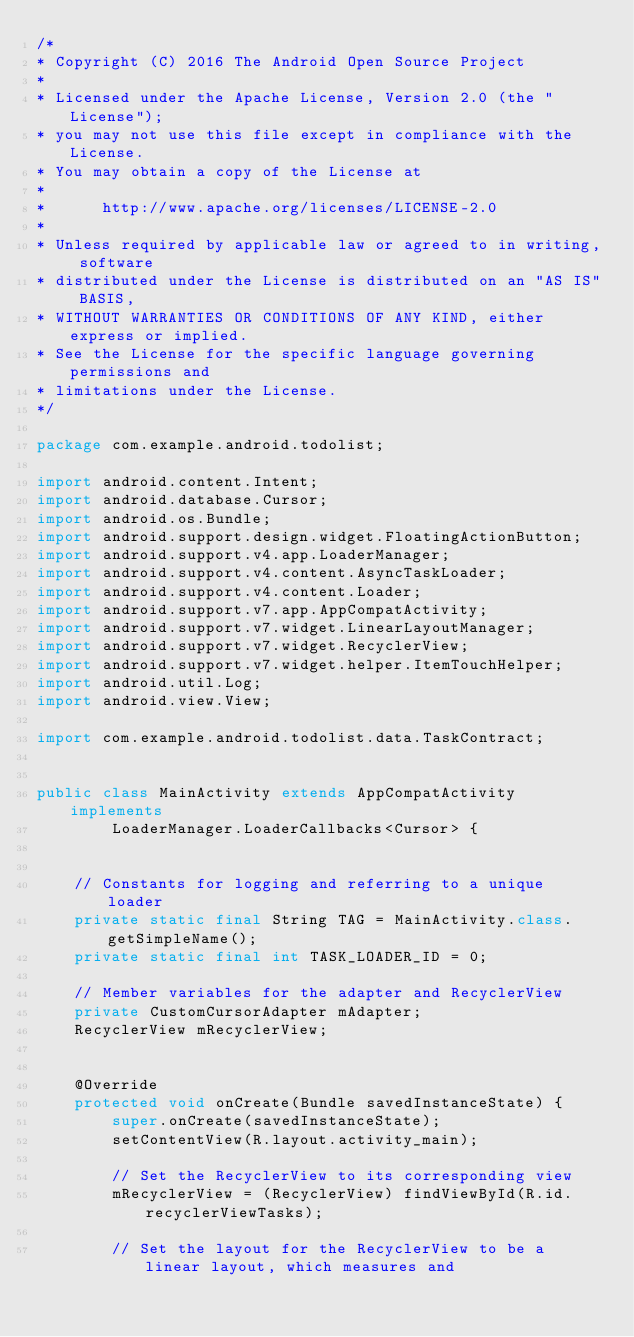Convert code to text. <code><loc_0><loc_0><loc_500><loc_500><_Java_>/*
* Copyright (C) 2016 The Android Open Source Project
*
* Licensed under the Apache License, Version 2.0 (the "License");
* you may not use this file except in compliance with the License.
* You may obtain a copy of the License at
*
*      http://www.apache.org/licenses/LICENSE-2.0
*
* Unless required by applicable law or agreed to in writing, software
* distributed under the License is distributed on an "AS IS" BASIS,
* WITHOUT WARRANTIES OR CONDITIONS OF ANY KIND, either express or implied.
* See the License for the specific language governing permissions and
* limitations under the License.
*/

package com.example.android.todolist;

import android.content.Intent;
import android.database.Cursor;
import android.os.Bundle;
import android.support.design.widget.FloatingActionButton;
import android.support.v4.app.LoaderManager;
import android.support.v4.content.AsyncTaskLoader;
import android.support.v4.content.Loader;
import android.support.v7.app.AppCompatActivity;
import android.support.v7.widget.LinearLayoutManager;
import android.support.v7.widget.RecyclerView;
import android.support.v7.widget.helper.ItemTouchHelper;
import android.util.Log;
import android.view.View;

import com.example.android.todolist.data.TaskContract;


public class MainActivity extends AppCompatActivity implements
        LoaderManager.LoaderCallbacks<Cursor> {


    // Constants for logging and referring to a unique loader
    private static final String TAG = MainActivity.class.getSimpleName();
    private static final int TASK_LOADER_ID = 0;

    // Member variables for the adapter and RecyclerView
    private CustomCursorAdapter mAdapter;
    RecyclerView mRecyclerView;


    @Override
    protected void onCreate(Bundle savedInstanceState) {
        super.onCreate(savedInstanceState);
        setContentView(R.layout.activity_main);

        // Set the RecyclerView to its corresponding view
        mRecyclerView = (RecyclerView) findViewById(R.id.recyclerViewTasks);

        // Set the layout for the RecyclerView to be a linear layout, which measures and</code> 